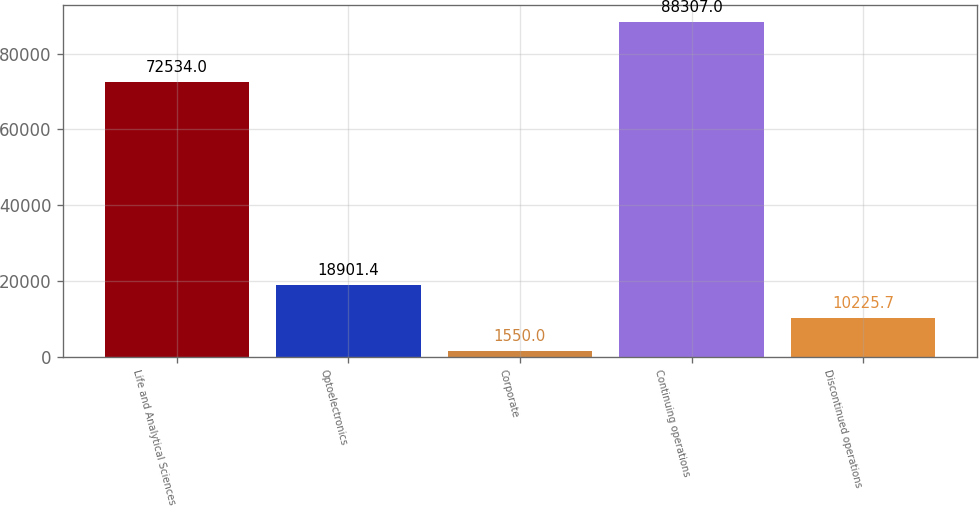Convert chart. <chart><loc_0><loc_0><loc_500><loc_500><bar_chart><fcel>Life and Analytical Sciences<fcel>Optoelectronics<fcel>Corporate<fcel>Continuing operations<fcel>Discontinued operations<nl><fcel>72534<fcel>18901.4<fcel>1550<fcel>88307<fcel>10225.7<nl></chart> 